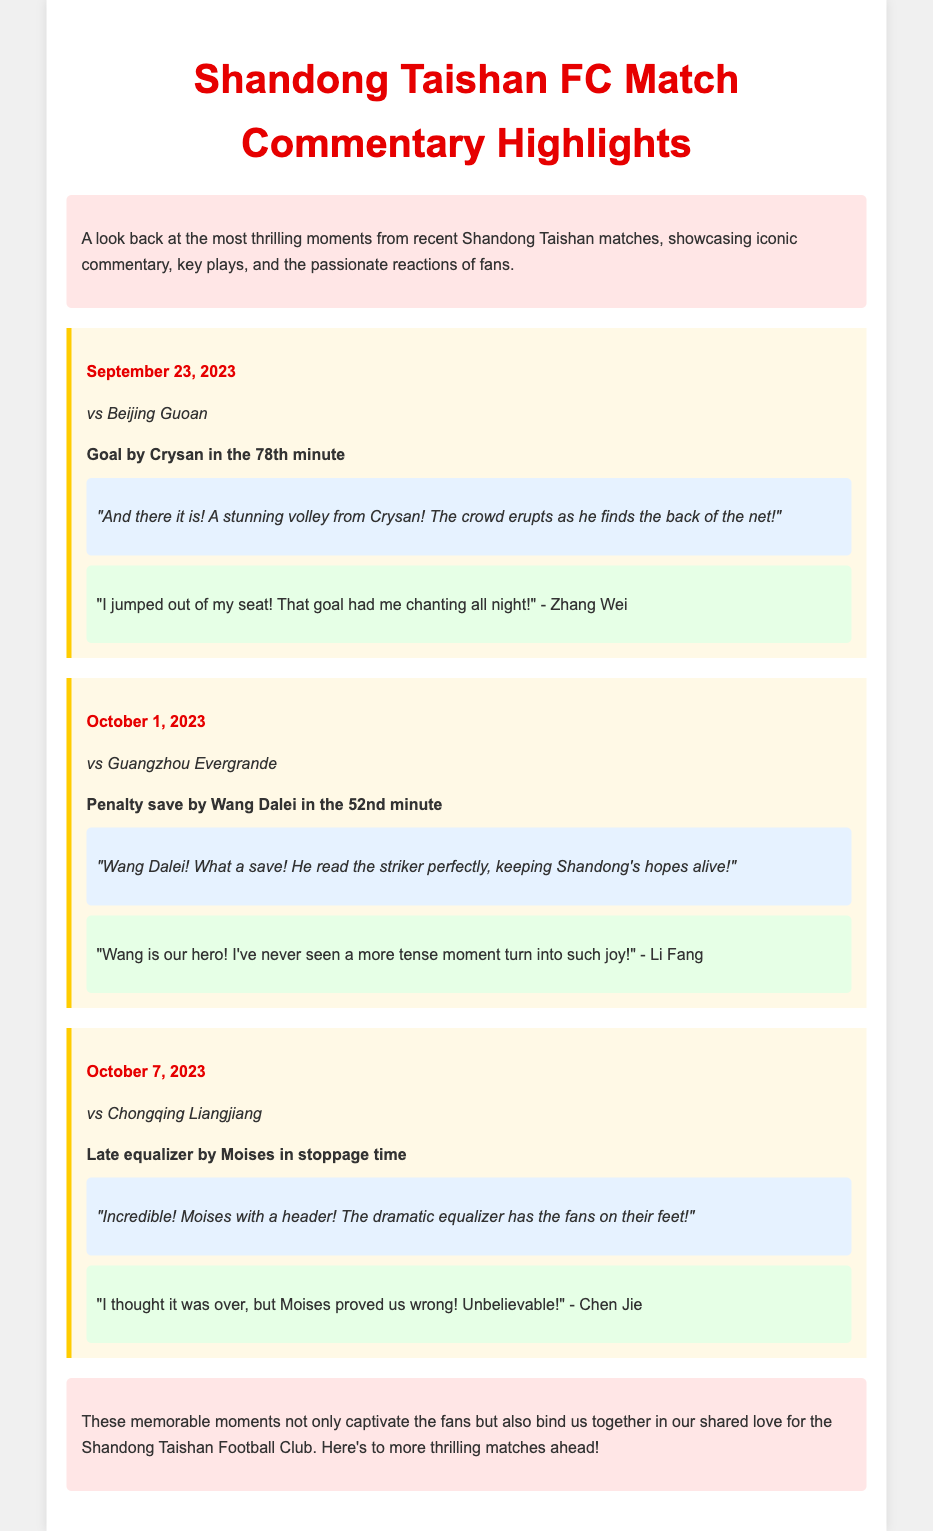What is the date of the match against Beijing Guoan? The date of the match against Beijing Guoan is specified in the document under the first highlight section.
Answer: September 23, 2023 Who scored a goal in the 78th minute against Beijing Guoan? The document identifies Crysan as the player who scored a goal in the 78th minute during the match against Beijing Guoan.
Answer: Crysan What significant event occurred in the 52nd minute of the match against Guangzhou Evergrande? The document highlights a penalty save made by Wang Dalei as the significant event in that minute of the match against Guangzhou Evergrande.
Answer: Penalty save What was the reaction of fan Zhang Wei to Crysan's goal? The document includes a fan quote from Zhang Wei regarding his reaction to Crysan's goal, detailing his excitement.
Answer: "I jumped out of my seat! That goal had me chanting all night!" What was the outcome of the match against Chongqing Liangjiang? The document reveals that the match against Chongqing Liangjiang featured a late equalizer by Moises, indicating that Shandong Taishan did not lose.
Answer: Equalizer 